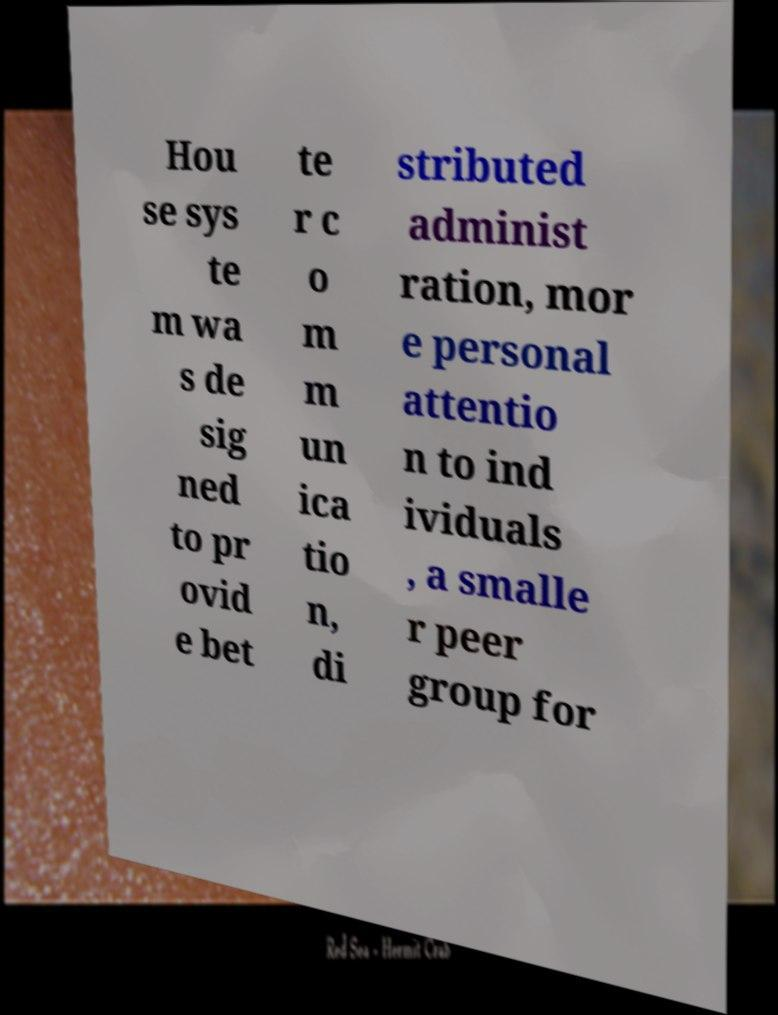Could you assist in decoding the text presented in this image and type it out clearly? Hou se sys te m wa s de sig ned to pr ovid e bet te r c o m m un ica tio n, di stributed administ ration, mor e personal attentio n to ind ividuals , a smalle r peer group for 